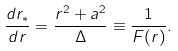Convert formula to latex. <formula><loc_0><loc_0><loc_500><loc_500>\frac { d r _ { * } } { d r } = \frac { r ^ { 2 } + a ^ { 2 } } { \Delta } \equiv \frac { 1 } { F ( r ) } .</formula> 